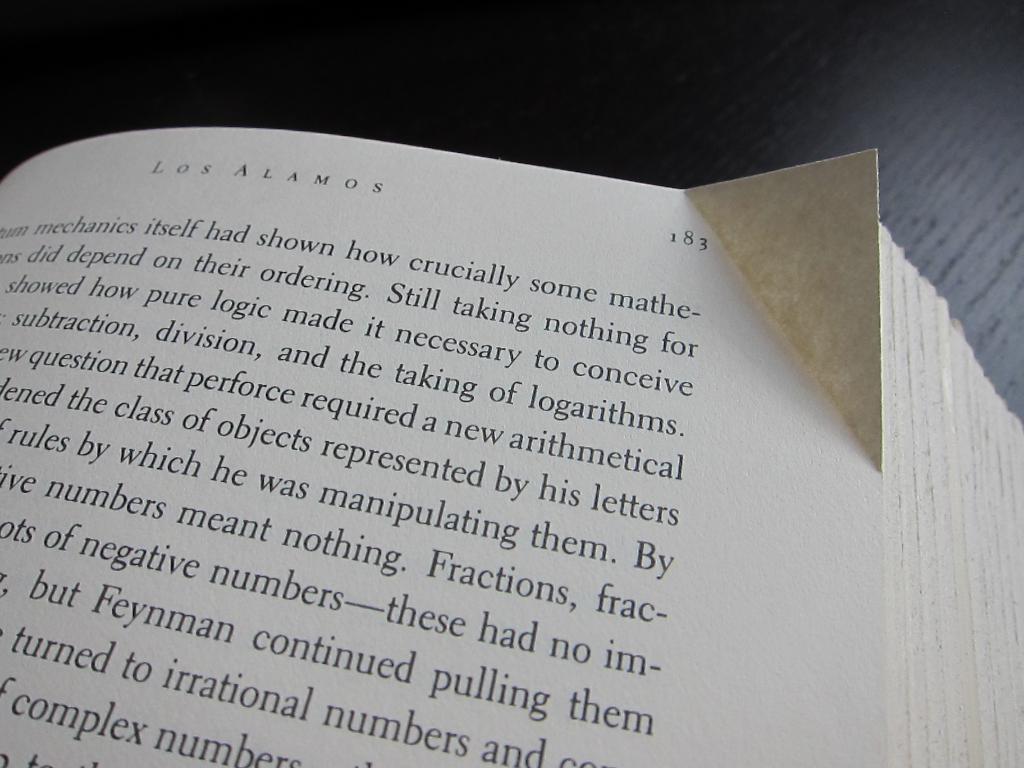What page number do we see?
Keep it short and to the point. 183. What is the name of this book?
Provide a short and direct response. Los alamos. 